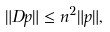Convert formula to latex. <formula><loc_0><loc_0><loc_500><loc_500>\| D p \| \leq n ^ { 2 } \| p \| ,</formula> 